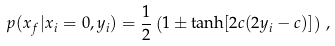<formula> <loc_0><loc_0><loc_500><loc_500>p ( x _ { f } | x _ { i } = 0 , y _ { i } ) = \frac { 1 } { 2 } \left ( 1 \pm \tanh [ 2 c ( 2 y _ { i } - c ) ] \right ) \, ,</formula> 